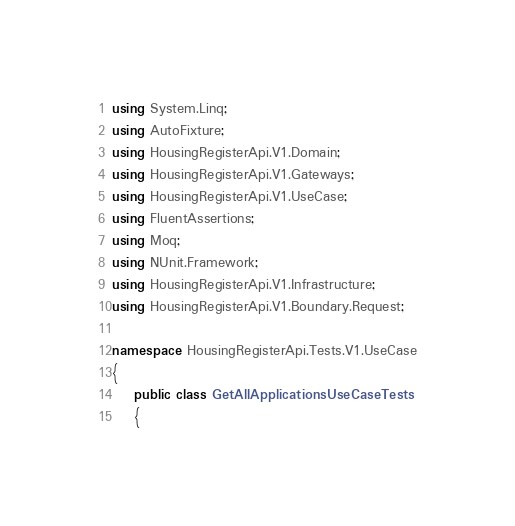Convert code to text. <code><loc_0><loc_0><loc_500><loc_500><_C#_>using System.Linq;
using AutoFixture;
using HousingRegisterApi.V1.Domain;
using HousingRegisterApi.V1.Gateways;
using HousingRegisterApi.V1.UseCase;
using FluentAssertions;
using Moq;
using NUnit.Framework;
using HousingRegisterApi.V1.Infrastructure;
using HousingRegisterApi.V1.Boundary.Request;

namespace HousingRegisterApi.Tests.V1.UseCase
{
    public class GetAllApplicationsUseCaseTests
    {</code> 